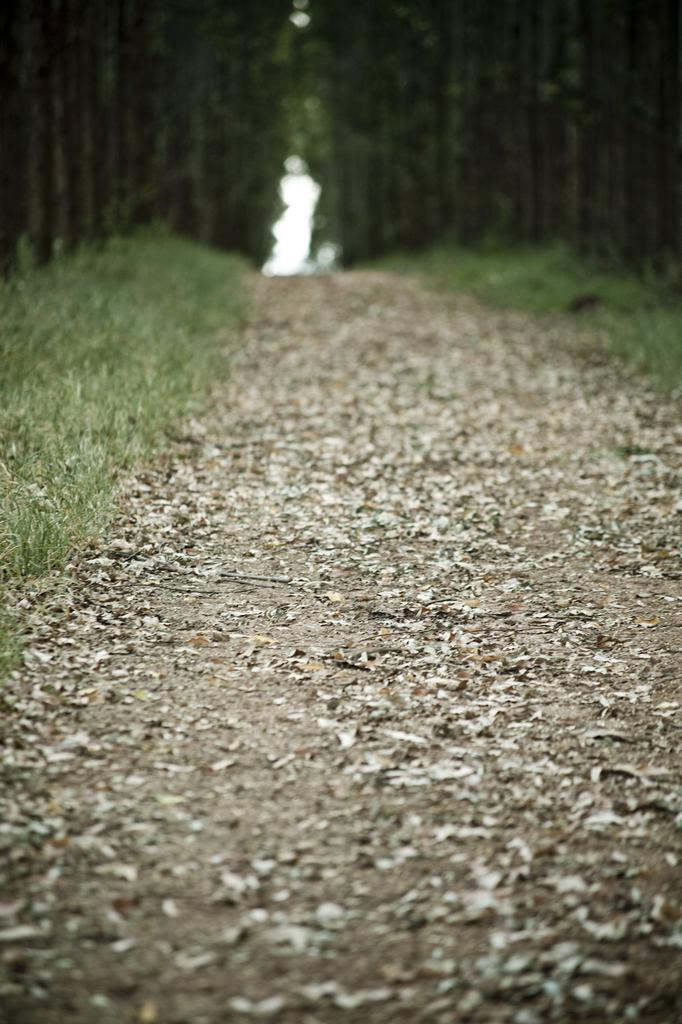What can be seen on the pathway in the image? There are dried leaves lying on the pathway. What type of vegetation is visible in the image? There is grass visible in the image. What can be seen in the background of the image? There are trees in the background of the image. What news is being reported by the hands in the image? There are no hands or news reports present in the image. What fact can be determined about the trees in the image? The fact that there are trees in the background of the image can be determined from the provided facts. 